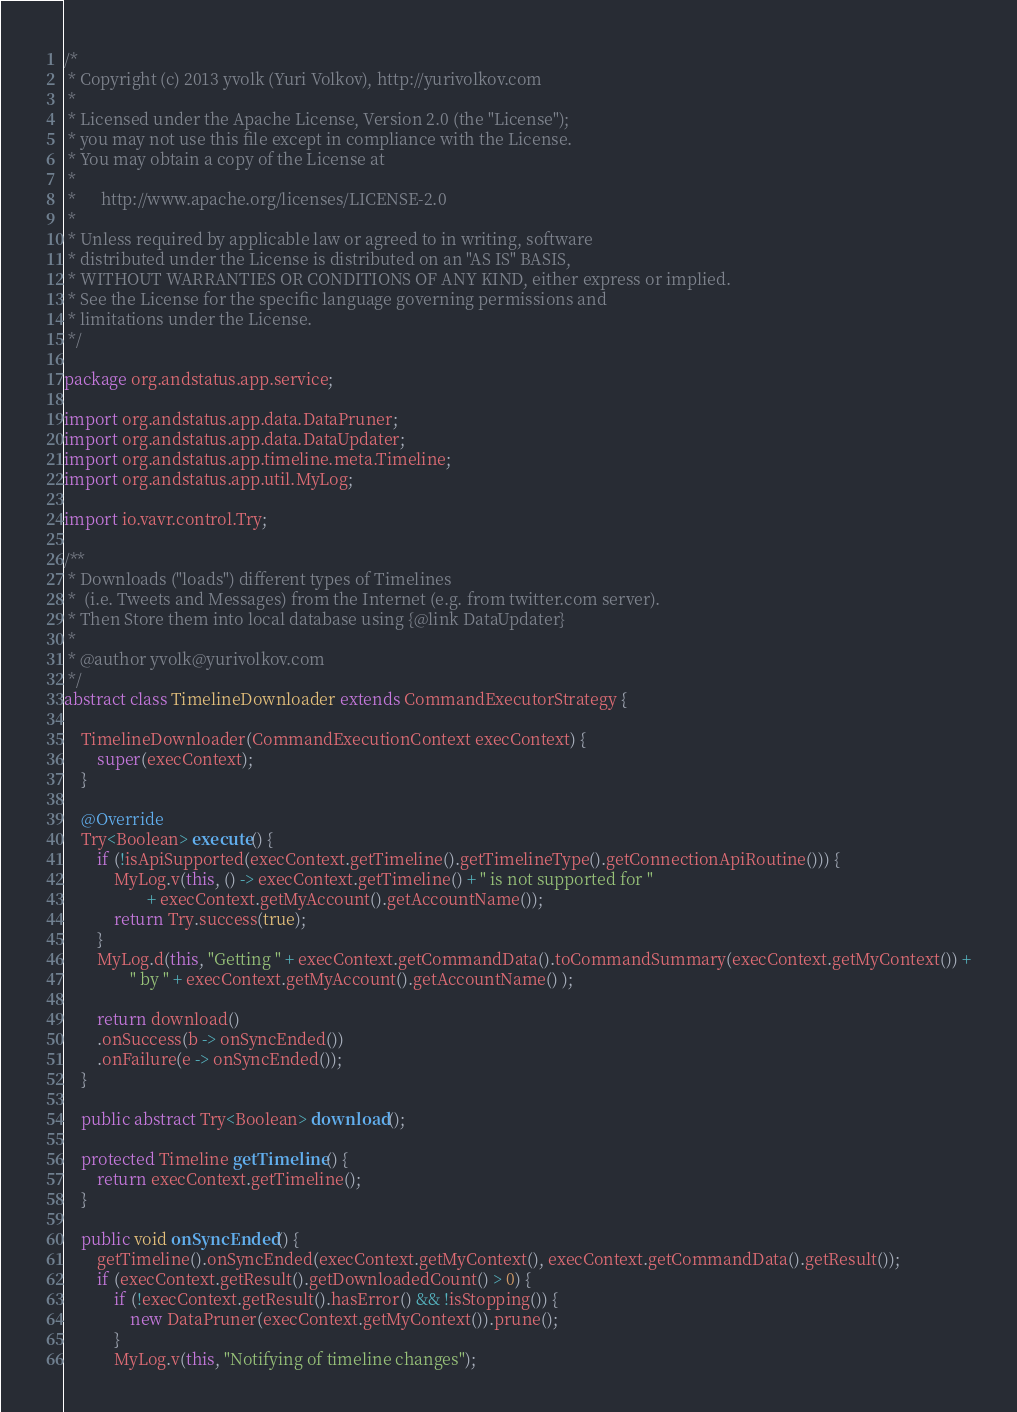<code> <loc_0><loc_0><loc_500><loc_500><_Java_>/* 
 * Copyright (c) 2013 yvolk (Yuri Volkov), http://yurivolkov.com
 *
 * Licensed under the Apache License, Version 2.0 (the "License");
 * you may not use this file except in compliance with the License.
 * You may obtain a copy of the License at
 *
 *      http://www.apache.org/licenses/LICENSE-2.0
 *
 * Unless required by applicable law or agreed to in writing, software
 * distributed under the License is distributed on an "AS IS" BASIS,
 * WITHOUT WARRANTIES OR CONDITIONS OF ANY KIND, either express or implied.
 * See the License for the specific language governing permissions and
 * limitations under the License.
 */

package org.andstatus.app.service;

import org.andstatus.app.data.DataPruner;
import org.andstatus.app.data.DataUpdater;
import org.andstatus.app.timeline.meta.Timeline;
import org.andstatus.app.util.MyLog;

import io.vavr.control.Try;

/**
 * Downloads ("loads") different types of Timelines 
 *  (i.e. Tweets and Messages) from the Internet (e.g. from twitter.com server).
 * Then Store them into local database using {@link DataUpdater}
 * 
 * @author yvolk@yurivolkov.com
 */
abstract class TimelineDownloader extends CommandExecutorStrategy {

    TimelineDownloader(CommandExecutionContext execContext) {
        super(execContext);
    }

    @Override
    Try<Boolean> execute() {
        if (!isApiSupported(execContext.getTimeline().getTimelineType().getConnectionApiRoutine())) {
            MyLog.v(this, () -> execContext.getTimeline() + " is not supported for "
                    + execContext.getMyAccount().getAccountName());
            return Try.success(true);
        }
        MyLog.d(this, "Getting " + execContext.getCommandData().toCommandSummary(execContext.getMyContext()) +
                " by " + execContext.getMyAccount().getAccountName() );

        return download()
        .onSuccess(b -> onSyncEnded())
        .onFailure(e -> onSyncEnded());
    }

    public abstract Try<Boolean> download();

    protected Timeline getTimeline() {
        return execContext.getTimeline();
    }

    public void onSyncEnded() {
        getTimeline().onSyncEnded(execContext.getMyContext(), execContext.getCommandData().getResult());
        if (execContext.getResult().getDownloadedCount() > 0) {
            if (!execContext.getResult().hasError() && !isStopping()) {
                new DataPruner(execContext.getMyContext()).prune();
            }
            MyLog.v(this, "Notifying of timeline changes");</code> 